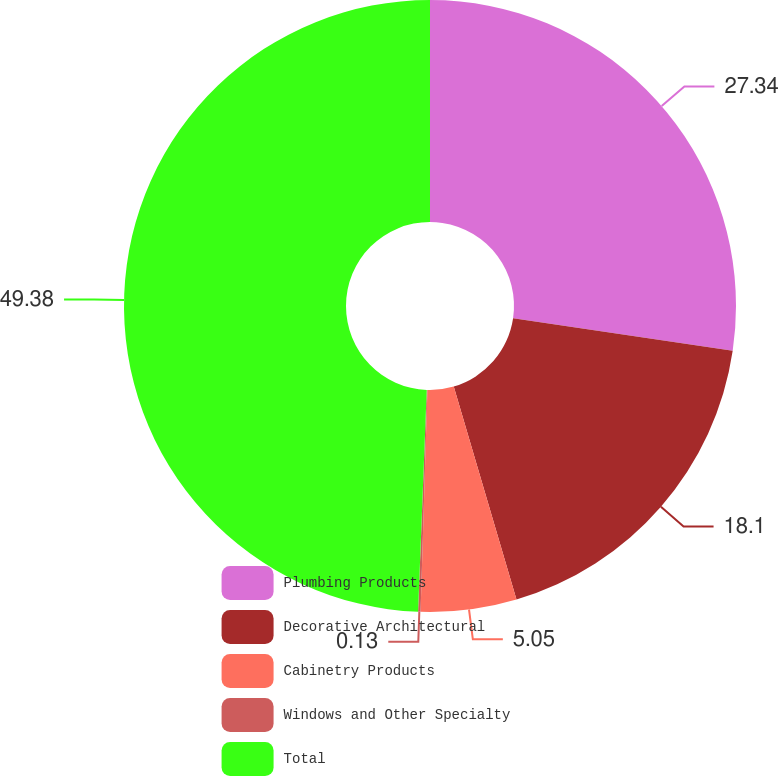Convert chart to OTSL. <chart><loc_0><loc_0><loc_500><loc_500><pie_chart><fcel>Plumbing Products<fcel>Decorative Architectural<fcel>Cabinetry Products<fcel>Windows and Other Specialty<fcel>Total<nl><fcel>27.34%<fcel>18.1%<fcel>5.05%<fcel>0.13%<fcel>49.38%<nl></chart> 